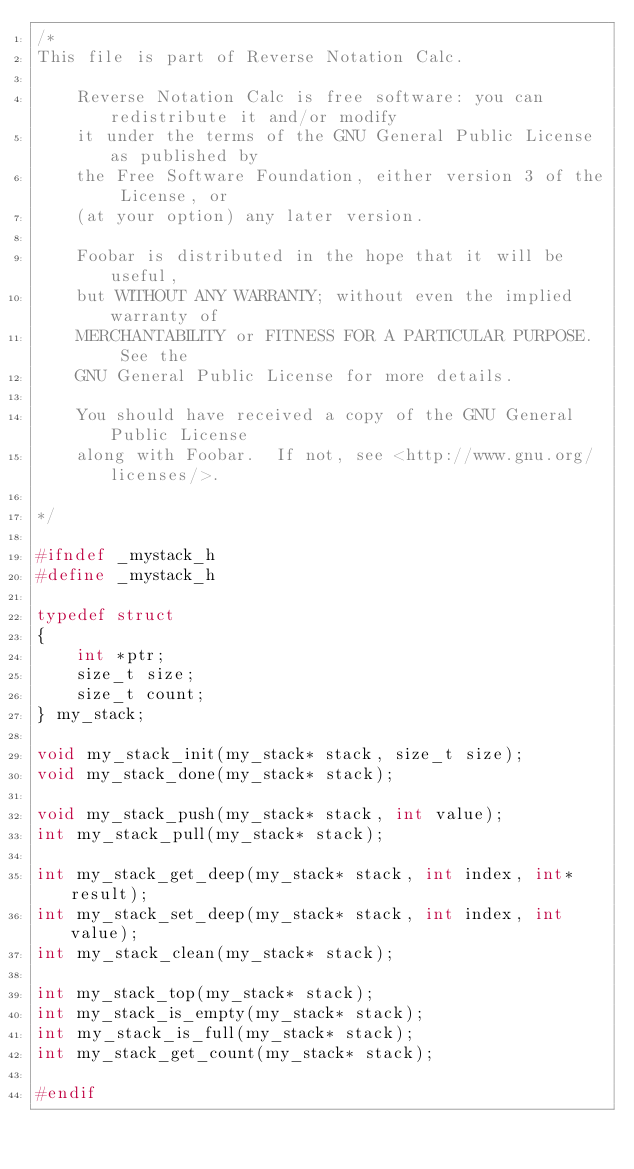<code> <loc_0><loc_0><loc_500><loc_500><_C_>/*
This file is part of Reverse Notation Calc.

    Reverse Notation Calc is free software: you can redistribute it and/or modify
    it under the terms of the GNU General Public License as published by
    the Free Software Foundation, either version 3 of the License, or
    (at your option) any later version.

    Foobar is distributed in the hope that it will be useful,
    but WITHOUT ANY WARRANTY; without even the implied warranty of
    MERCHANTABILITY or FITNESS FOR A PARTICULAR PURPOSE.  See the
    GNU General Public License for more details.

    You should have received a copy of the GNU General Public License
    along with Foobar.  If not, see <http://www.gnu.org/licenses/>.

*/

#ifndef _mystack_h
#define _mystack_h

typedef struct 
{
    int *ptr;
    size_t size;
    size_t count;
} my_stack;

void my_stack_init(my_stack* stack, size_t size);
void my_stack_done(my_stack* stack);

void my_stack_push(my_stack* stack, int value);
int my_stack_pull(my_stack* stack);

int my_stack_get_deep(my_stack* stack, int index, int* result);
int my_stack_set_deep(my_stack* stack, int index, int value);
int my_stack_clean(my_stack* stack);

int my_stack_top(my_stack* stack);
int my_stack_is_empty(my_stack* stack);
int my_stack_is_full(my_stack* stack);
int my_stack_get_count(my_stack* stack);

#endif
</code> 